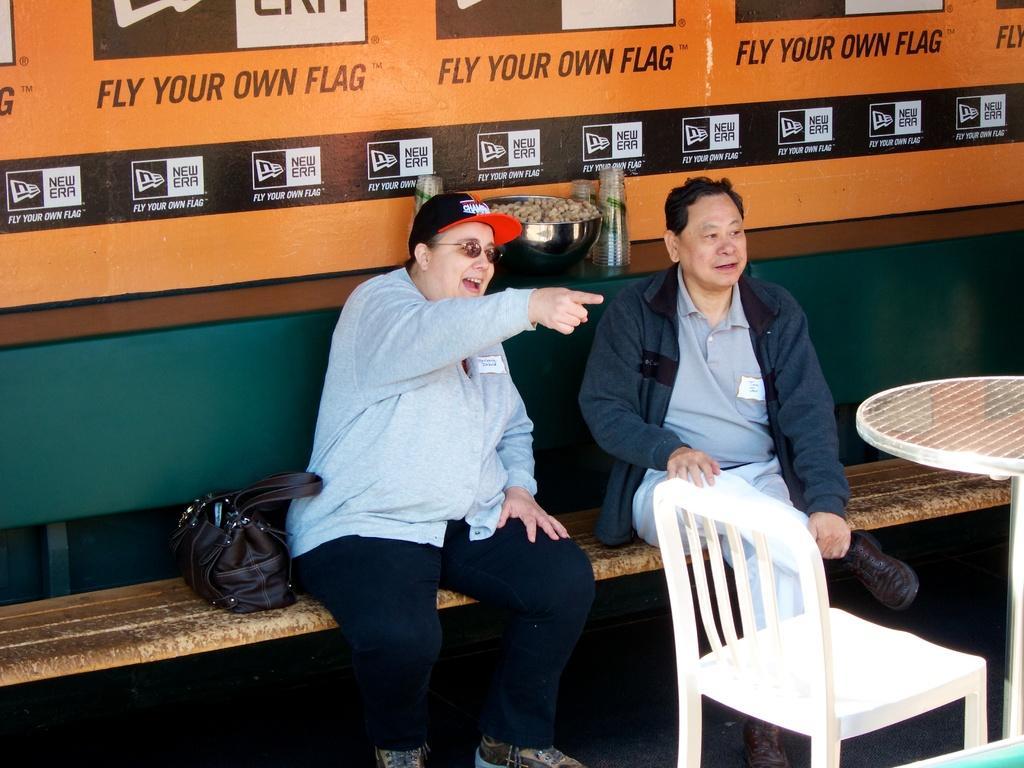How would you summarize this image in a sentence or two? In this image i can see two persons are sitting on the bench. Beside these persons,there is a hand bag,chair,table and in the background i can see some objects. 